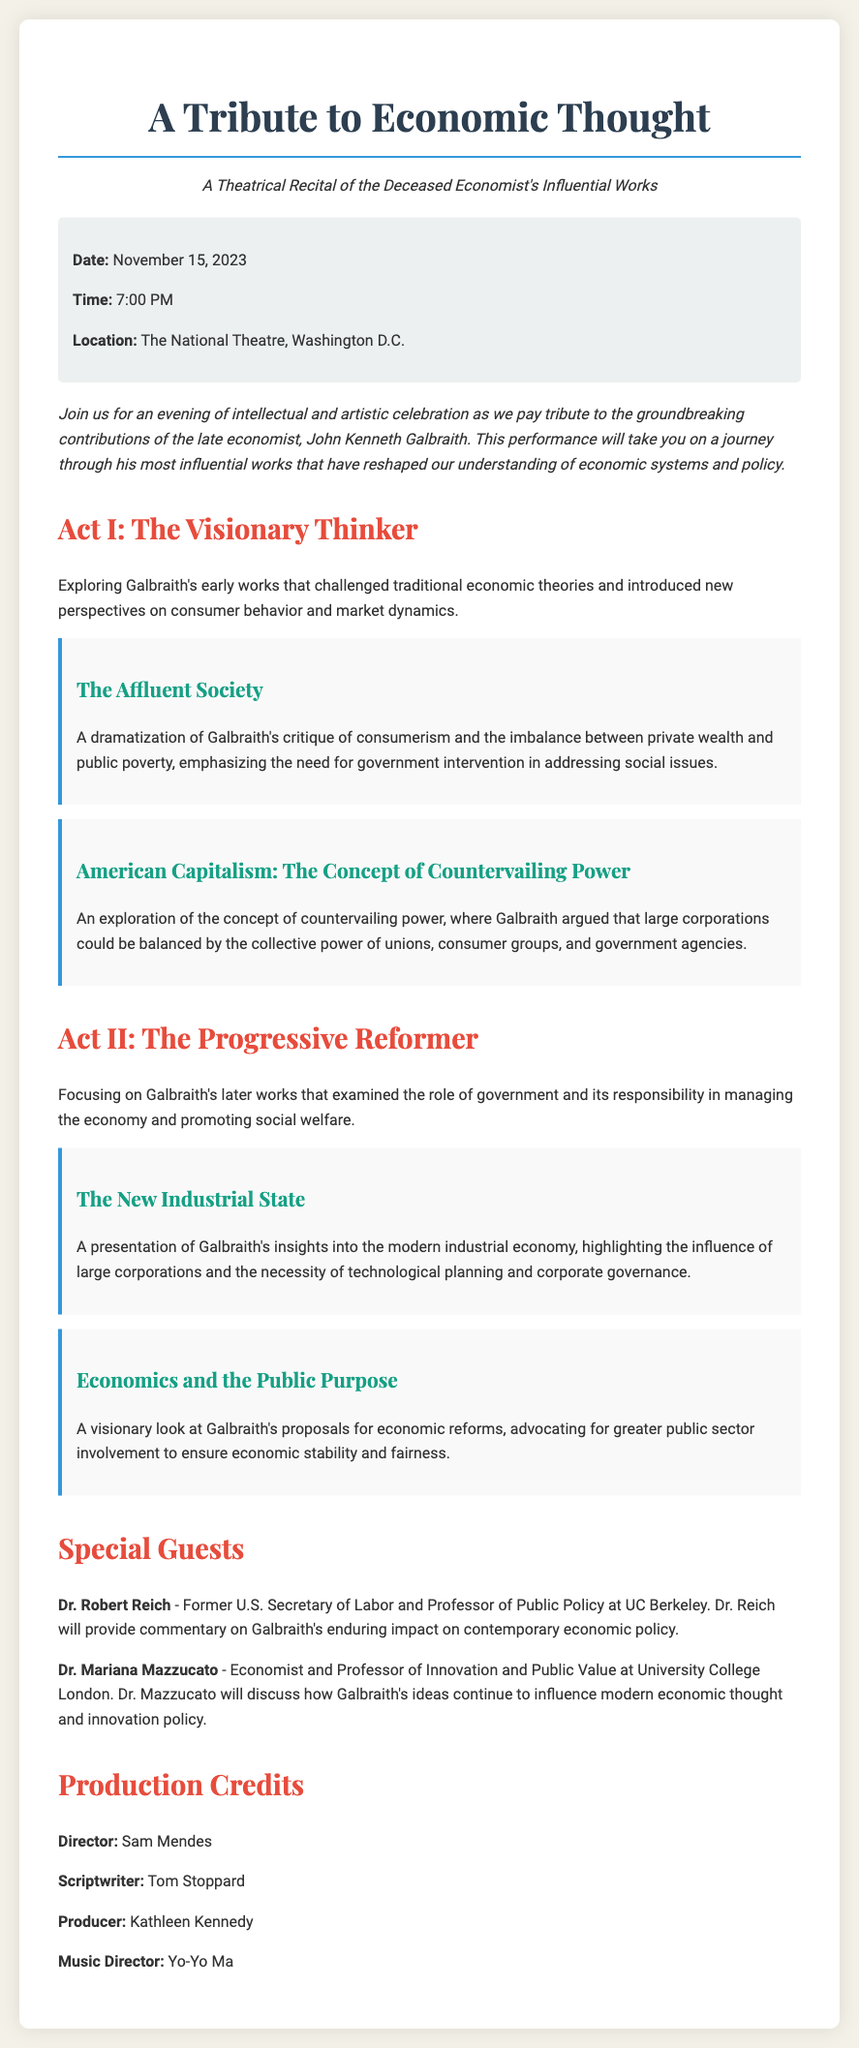What is the event date? The date is explicitly mentioned in the document as November 15, 2023.
Answer: November 15, 2023 What is the location of the event? The document specifies that the event will take place at The National Theatre, Washington D.C.
Answer: The National Theatre, Washington D.C Who is the director of the production? The document lists the director as Sam Mendes.
Answer: Sam Mendes What is the subtitle of the playbill? The subtitle provides additional context about the performance, stating it is a theatrical recital of the deceased economist's influential works.
Answer: A Theatrical Recital of the Deceased Economist's Influential Works What is the main theme of Act I? Act I focuses on Galbraith's early works and their impact on economic theories, which is outlined in the description of the act.
Answer: The Visionary Thinker Who is one of the special guests? The document names Dr. Robert Reich as a special guest.
Answer: Dr. Robert Reich What does "The Affluent Society" emphasize? This work critiques consumerism and the imbalance between private wealth and public poverty, as stated in the highlight section.
Answer: Government intervention What is the role of Dr. Mariana Mazzucato at the event? Dr. Mazzucato is mentioned as discussing Galbraith's influence on modern economic thought and innovation policy.
Answer: Discussing Galbraith's ideas What is the focus of Act II? The focus of Act II revolves around Galbraith's later works concerning government roles and responsibilities in the economy.
Answer: The Progressive Reformer 